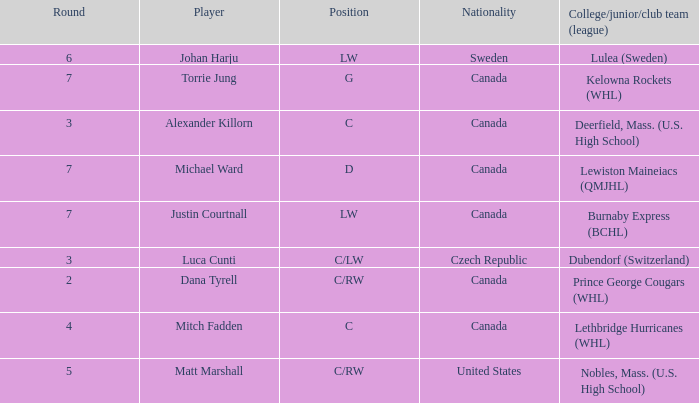What College/junior/club team (league) did mitch fadden play for? Lethbridge Hurricanes (WHL). 